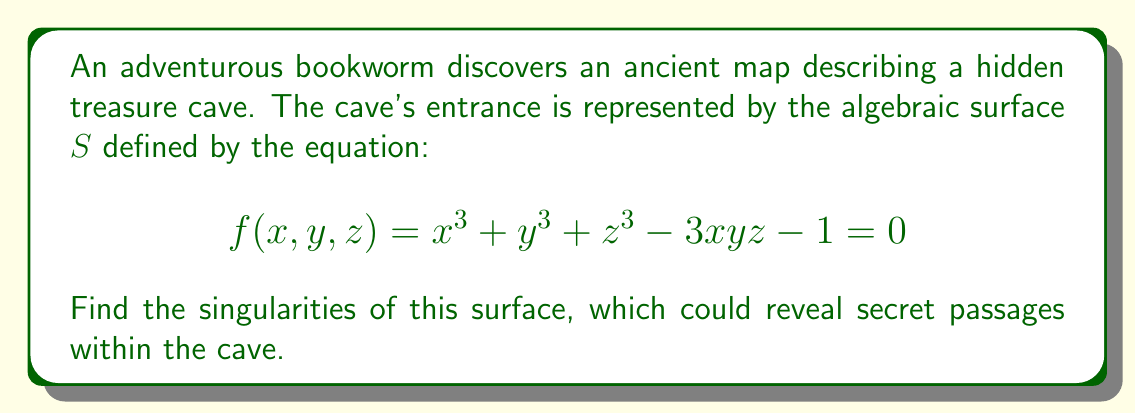Show me your answer to this math problem. To find the singularities of the surface, we need to follow these steps:

1) The singularities occur at points where all partial derivatives of $f$ are zero simultaneously. Let's calculate these partial derivatives:

   $$\frac{\partial f}{\partial x} = 3x^2 - 3yz$$
   $$\frac{\partial f}{\partial y} = 3y^2 - 3xz$$
   $$\frac{\partial f}{\partial z} = 3z^2 - 3xy$$

2) Set each partial derivative to zero:

   $$3x^2 - 3yz = 0$$
   $$3y^2 - 3xz = 0$$
   $$3z^2 - 3xy = 0$$

3) From these equations, we can deduce:
   
   $$x^2 = yz$$
   $$y^2 = xz$$
   $$z^2 = xy$$

4) Multiplying these equations:

   $$x^2y^2z^2 = y^2z^2x^2$$

   This is always true, so it doesn't give us any new information.

5) Let's consider the possibilities:
   - If any of $x$, $y$, or $z$ is zero, the others must also be zero to satisfy the equations.
   - If none are zero, then from $x^2 = yz$ and $y^2 = xz$, we can deduce $x^4 = x^2y^2 = (yz)^2 = x^2z^2$, which implies $x^2 = z^2$.
   
6) Similarly, we can show $x^2 = y^2 = z^2$. This means $x = \pm y = \pm z$.

7) Substituting this back into the original equation:

   $$(\pm 1)^3 + (\pm 1)^3 + (\pm 1)^3 - 3(\pm 1)(\pm 1)(\pm 1) - 1 = 0$$

   $$3 - 3 - 1 = -1 \neq 0$$

   This means there are no non-zero solutions.

8) Therefore, the only singularity is at $(0,0,0)$.

9) We should verify that $(0,0,0)$ satisfies the original equation:

   $$f(0,0,0) = 0^3 + 0^3 + 0^3 - 3(0)(0)(0) - 1 = -1 \neq 0$$

   This means $(0,0,0)$ is not on the surface, so it's not a singularity of $S$.

Therefore, the surface $S$ has no singularities.
Answer: No singularities 